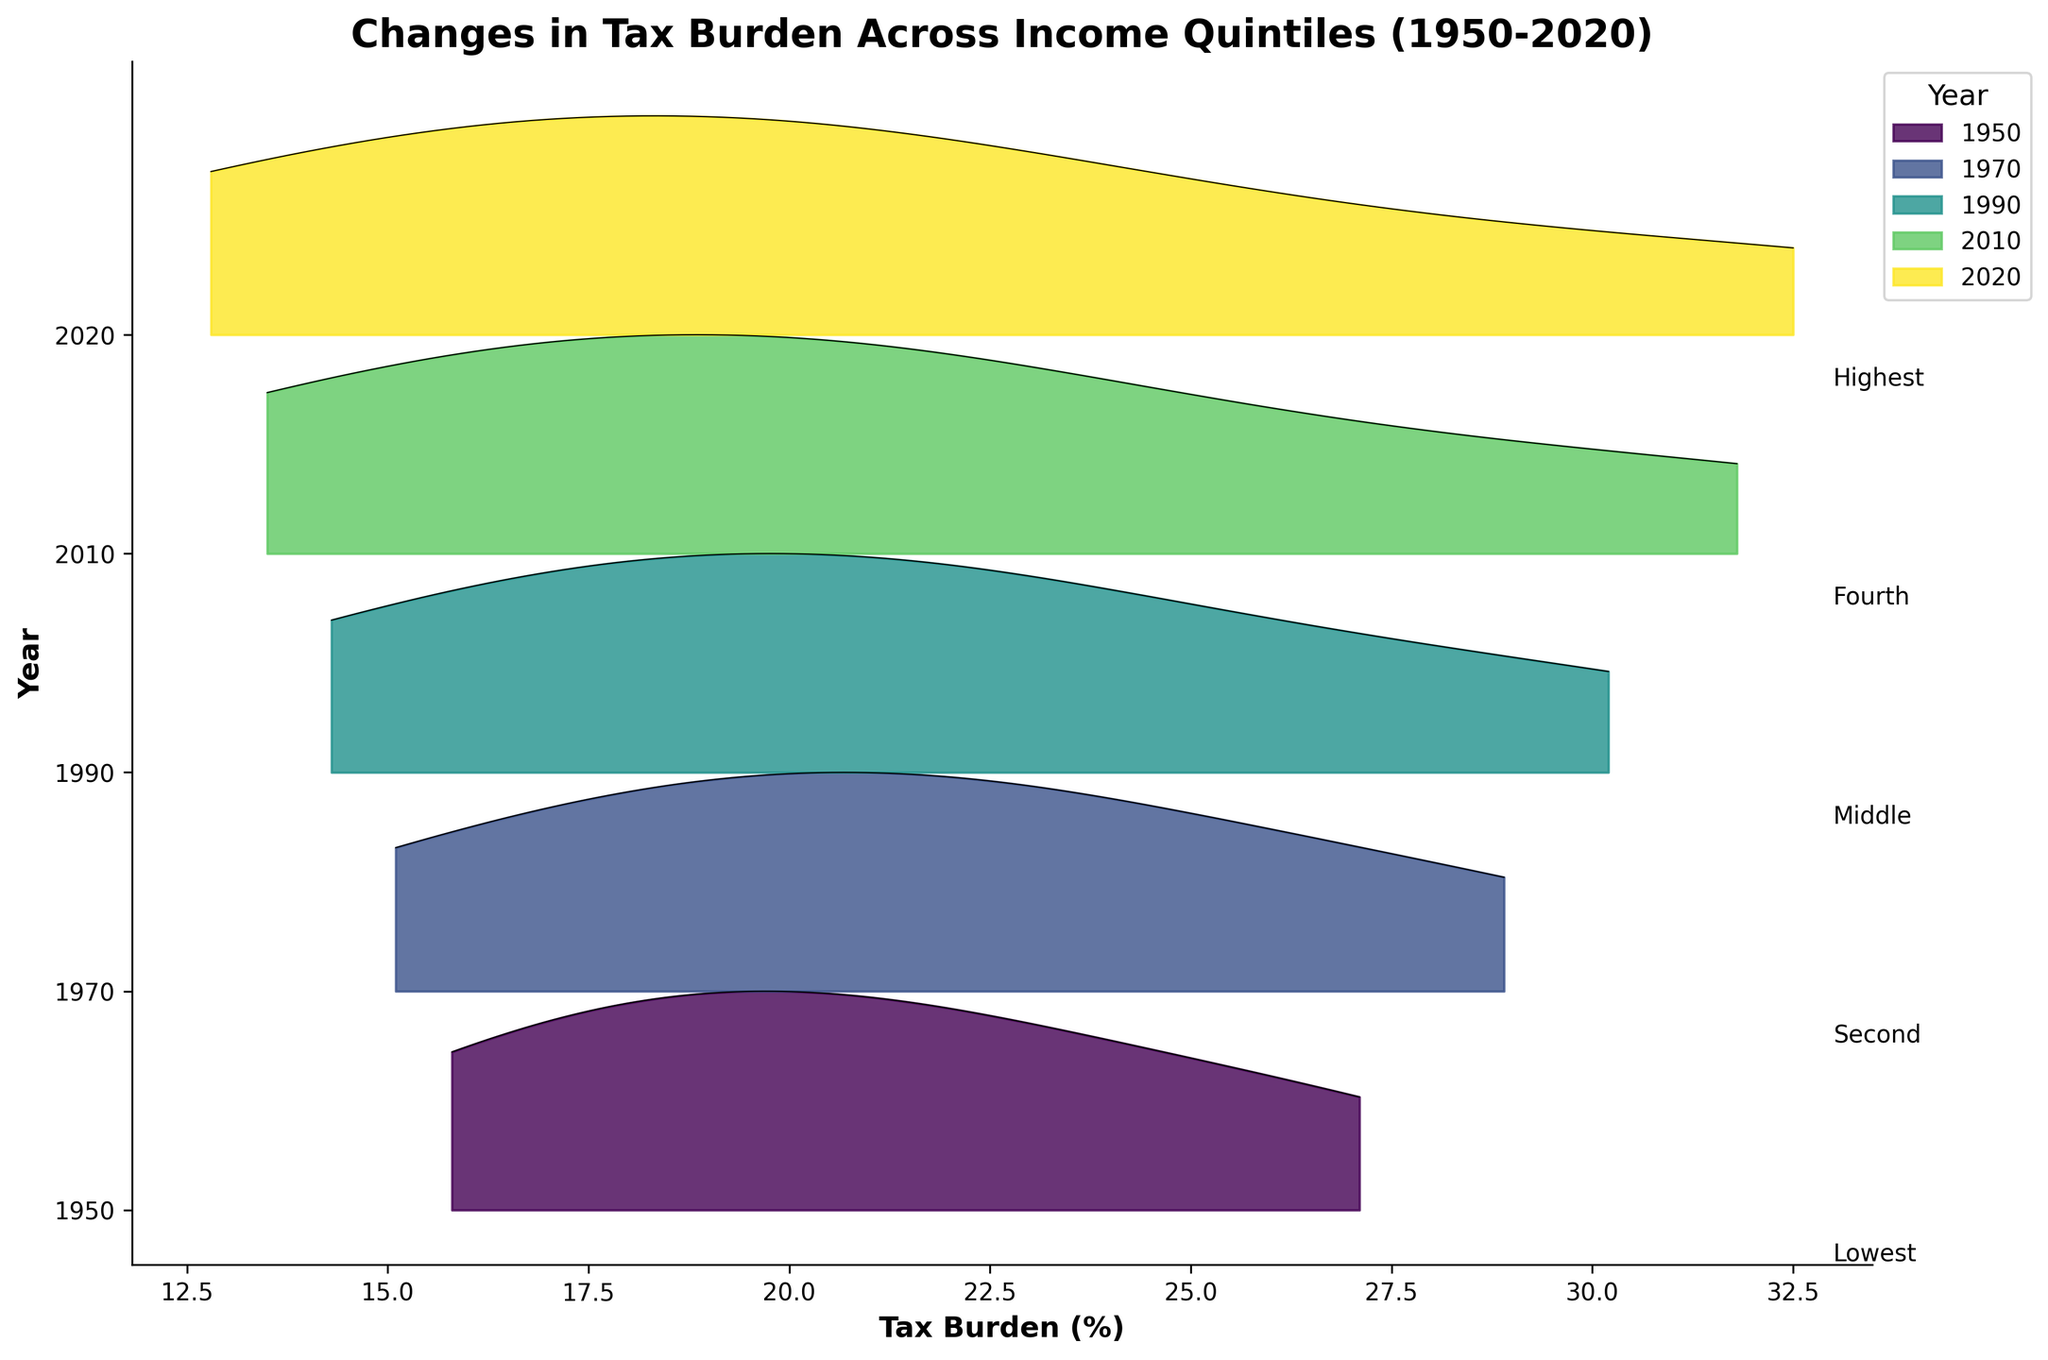What is the title of the plot? The title of the plot is prominently displayed at the top, summarizing the visualization's key topic.
Answer: Changes in Tax Burden Across Income Quintiles (1950-2020) What is the x-axis label? The x-axis label is shown below the horizontal axis, describing what the x-axis represents.
Answer: Tax Burden (%) Which year has the highest tax burden for the highest quintile? The highest point along the ridgeline for the highest quintile indicates the maximum tax burden. Compare the labels to identify the corresponding year.
Answer: 2020 How does the tax burden for the second quintile in 1950 compare to the tax burden for the second quintile in 1990? Look at the y-axis for 1950 and 1990, then find the second quintile’s tax burden line for each year and compare their values.
Answer: The tax burden decreased from 18.2% to 17.9% What is the trend in the tax burden for the lowest quintile from 1950 to 2020? Trace the ridgeline for the lowest quintile across the years to identify if it increases, decreases, or remains stable over time.
Answer: Decreasing trend Among the years depicted, which year has the least variation in tax burdens across all quintiles? Variation is minimal when the ridgeline’s spread from the lowest to the highest quintile is small. Identify the year with the tightest spread.
Answer: 1950 Which quintile shows the greatest increase in tax burden from 1950 to 2020? Calculate the difference in tax burdens for each quintile between 1950 and 2020 and determine the greatest increase.
Answer: Highest quintile How many years are visualized in the plot? The years are labeled along the y-axis, each representing a different horizontal layer in the plot. Count these labels.
Answer: 5 Is there any year where the tax burden for the middle quintile did not change significantly compared to the previous year? Compare the positions and shapes of the ridgelines for the middle quintile between consecutive years to identify minimal changes.
Answer: Relatively stable between 1990 and 2010 